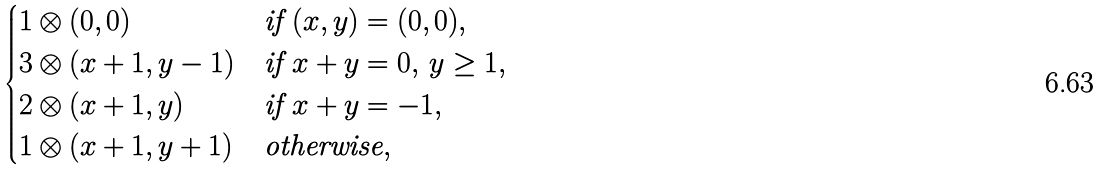Convert formula to latex. <formula><loc_0><loc_0><loc_500><loc_500>\begin{cases} 1 \otimes ( 0 , 0 ) & \text {if $(x,y) = (0,0)$} , \\ 3 \otimes ( x + 1 , y - 1 ) & \text {if $x+y=0, \,y \geq 1$} , \\ 2 \otimes ( x + 1 , y ) & \text {if $x + y = -1$} , \\ 1 \otimes ( x + 1 , y + 1 ) & \text {otherwise} , \end{cases}</formula> 